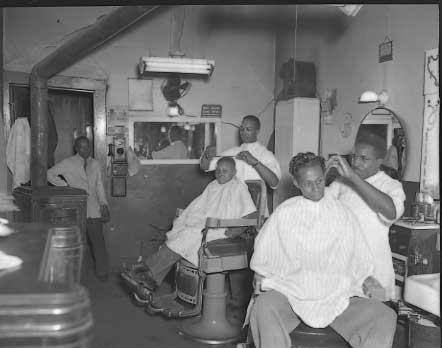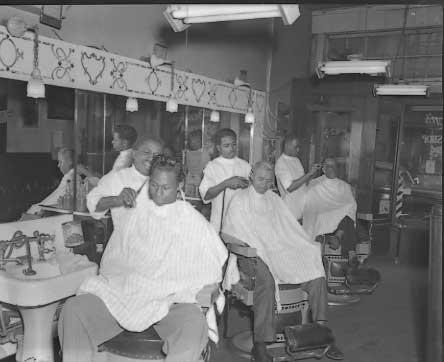The first image is the image on the left, the second image is the image on the right. Examine the images to the left and right. Is the description "Five barbers are working with customers seated in chairs." accurate? Answer yes or no. Yes. The first image is the image on the left, the second image is the image on the right. Given the left and right images, does the statement "There are exactly two men sitting in barbers chairs in the image on the right." hold true? Answer yes or no. No. 